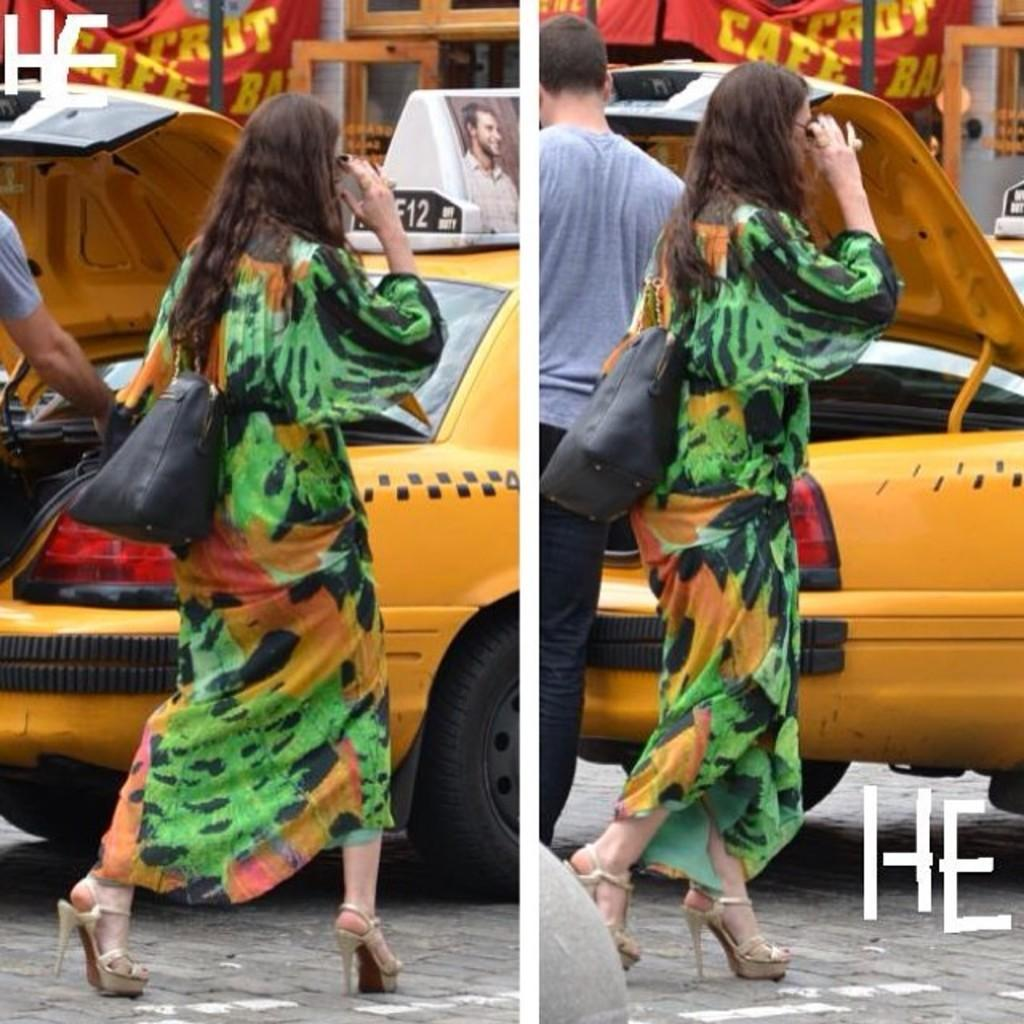<image>
Provide a brief description of the given image. A woman in a green dress walks down a street and letter H an E are in the lower right and upper left corner. 